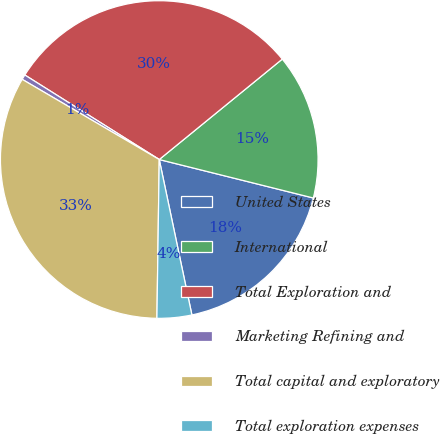<chart> <loc_0><loc_0><loc_500><loc_500><pie_chart><fcel>United States<fcel>International<fcel>Total Exploration and<fcel>Marketing Refining and<fcel>Total capital and exploratory<fcel>Total exploration expenses<nl><fcel>17.81%<fcel>14.79%<fcel>30.17%<fcel>0.51%<fcel>33.19%<fcel>3.53%<nl></chart> 